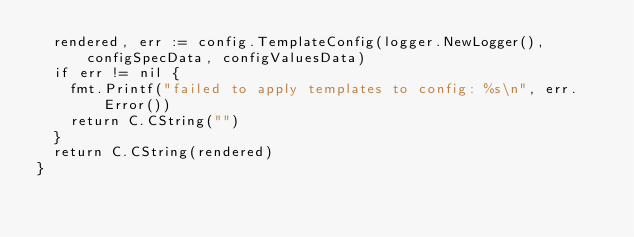<code> <loc_0><loc_0><loc_500><loc_500><_Go_>	rendered, err := config.TemplateConfig(logger.NewLogger(), configSpecData, configValuesData)
	if err != nil {
		fmt.Printf("failed to apply templates to config: %s\n", err.Error())
		return C.CString("")
	}
	return C.CString(rendered)
}
</code> 